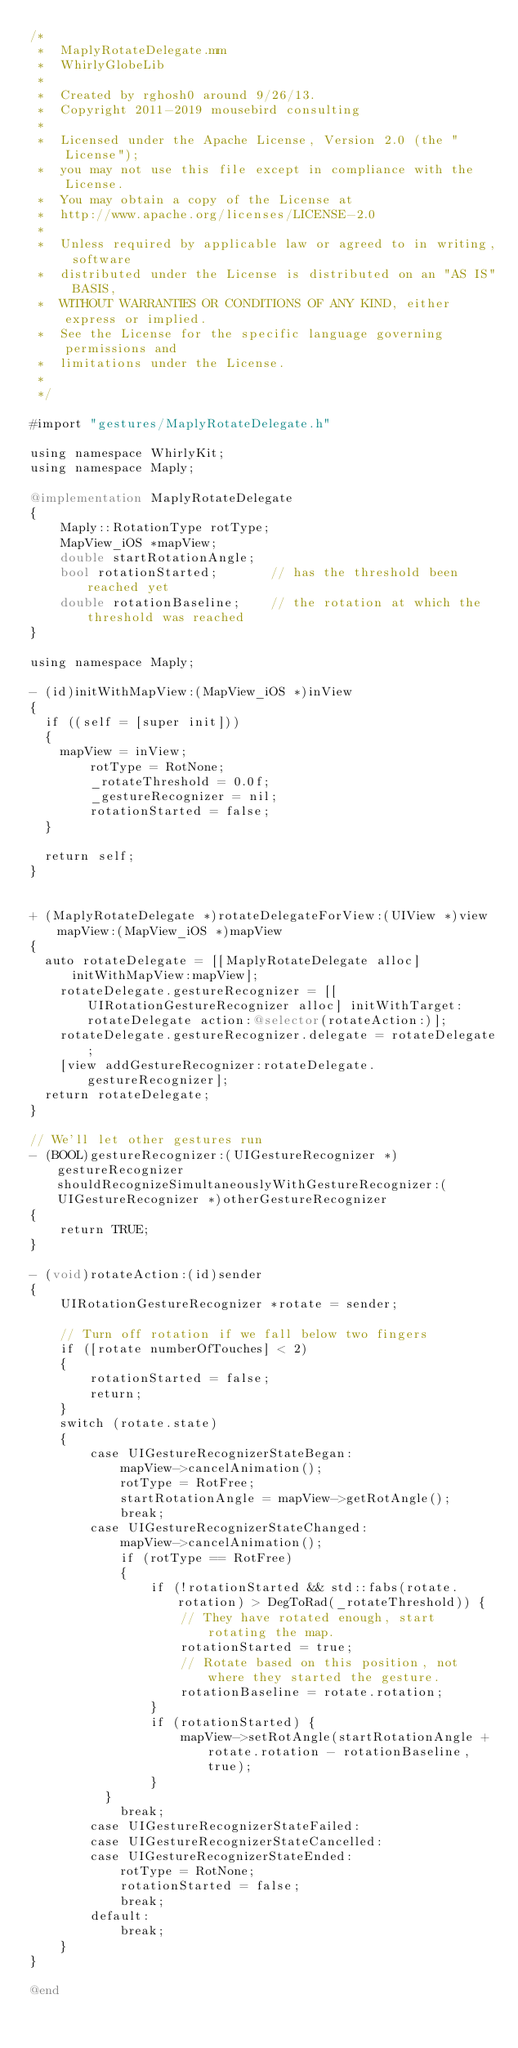<code> <loc_0><loc_0><loc_500><loc_500><_ObjectiveC_>/*
 *  MaplyRotateDelegate.mm
 *  WhirlyGlobeLib
 *
 *  Created by rghosh0 around 9/26/13.
 *  Copyright 2011-2019 mousebird consulting
 *
 *  Licensed under the Apache License, Version 2.0 (the "License");
 *  you may not use this file except in compliance with the License.
 *  You may obtain a copy of the License at
 *  http://www.apache.org/licenses/LICENSE-2.0
 *
 *  Unless required by applicable law or agreed to in writing, software
 *  distributed under the License is distributed on an "AS IS" BASIS,
 *  WITHOUT WARRANTIES OR CONDITIONS OF ANY KIND, either express or implied.
 *  See the License for the specific language governing permissions and
 *  limitations under the License.
 *
 */

#import "gestures/MaplyRotateDelegate.h"

using namespace WhirlyKit;
using namespace Maply;

@implementation MaplyRotateDelegate
{
    Maply::RotationType rotType;
    MapView_iOS *mapView;
    double startRotationAngle;
    bool rotationStarted;       // has the threshold been reached yet
    double rotationBaseline;    // the rotation at which the threshold was reached
}

using namespace Maply;

- (id)initWithMapView:(MapView_iOS *)inView
{
	if ((self = [super init]))
	{
		mapView = inView;
        rotType = RotNone;
        _rotateThreshold = 0.0f;
        _gestureRecognizer = nil;
        rotationStarted = false;
	}
	
	return self;
}


+ (MaplyRotateDelegate *)rotateDelegateForView:(UIView *)view mapView:(MapView_iOS *)mapView
{
	auto rotateDelegate = [[MaplyRotateDelegate alloc] initWithMapView:mapView];
    rotateDelegate.gestureRecognizer = [[UIRotationGestureRecognizer alloc] initWithTarget:rotateDelegate action:@selector(rotateAction:)];
    rotateDelegate.gestureRecognizer.delegate = rotateDelegate;
    [view addGestureRecognizer:rotateDelegate.gestureRecognizer];
	return rotateDelegate;
}

// We'll let other gestures run
- (BOOL)gestureRecognizer:(UIGestureRecognizer *)gestureRecognizer shouldRecognizeSimultaneouslyWithGestureRecognizer:(UIGestureRecognizer *)otherGestureRecognizer
{
    return TRUE;
}

- (void)rotateAction:(id)sender
{
    UIRotationGestureRecognizer *rotate = sender;
    
    // Turn off rotation if we fall below two fingers
    if ([rotate numberOfTouches] < 2)
    {
        rotationStarted = false;
        return;
    }
    switch (rotate.state)
    {
        case UIGestureRecognizerStateBegan:
            mapView->cancelAnimation();
            rotType = RotFree;
            startRotationAngle = mapView->getRotAngle();
            break;
        case UIGestureRecognizerStateChanged:
            mapView->cancelAnimation();
            if (rotType == RotFree)
            {
                if (!rotationStarted && std::fabs(rotate.rotation) > DegToRad(_rotateThreshold)) {
                    // They have rotated enough, start rotating the map.
                    rotationStarted = true;
                    // Rotate based on this position, not where they started the gesture.
                    rotationBaseline = rotate.rotation;
                }
                if (rotationStarted) {
                    mapView->setRotAngle(startRotationAngle + rotate.rotation - rotationBaseline, true);
                }
	        }
            break;
        case UIGestureRecognizerStateFailed:
        case UIGestureRecognizerStateCancelled:
        case UIGestureRecognizerStateEnded:
            rotType = RotNone;
            rotationStarted = false;
            break;
        default:
            break;
    }
}

@end
</code> 